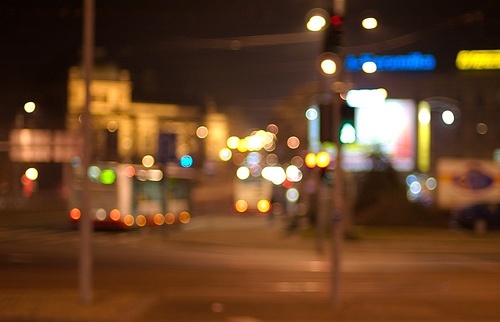Describe the objects in this image and their specific colors. I can see bus in black, maroon, brown, and gray tones, truck in black, brown, maroon, and salmon tones, and traffic light in black, white, maroon, and darkgreen tones in this image. 